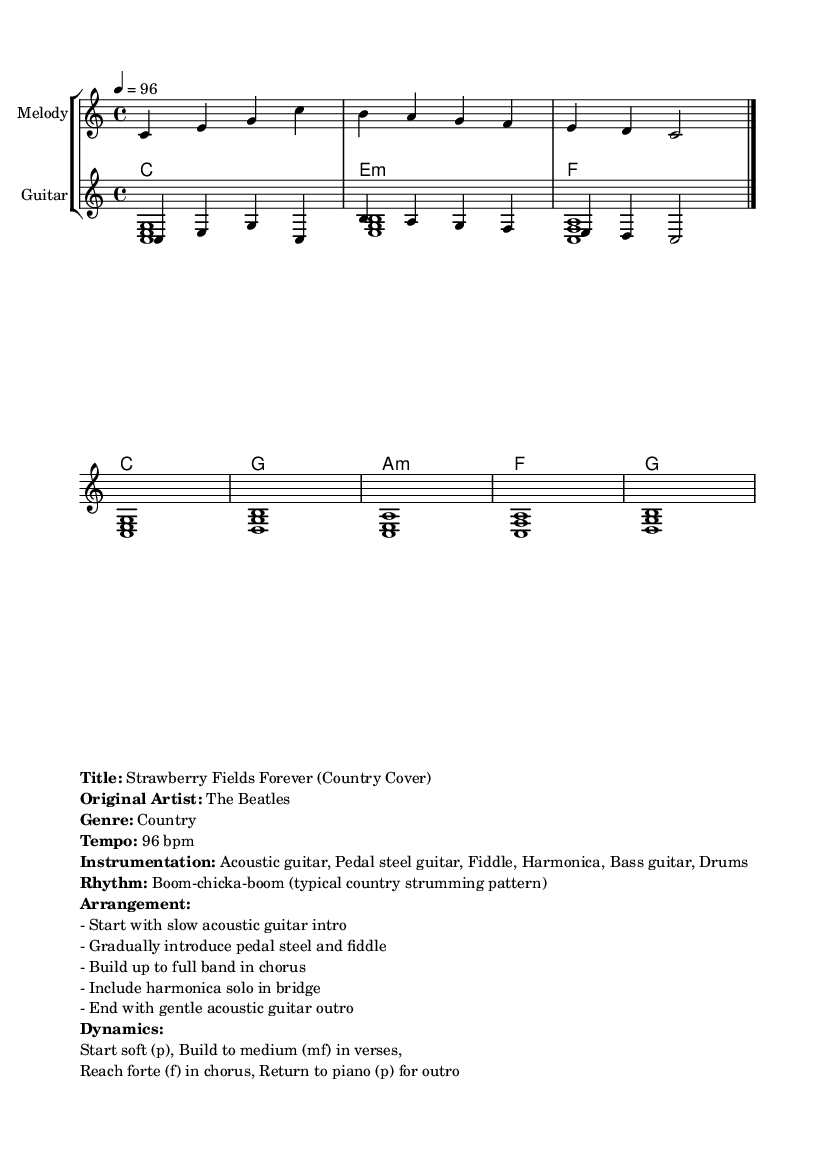What is the key signature of this music? The key signature is C major, which has no sharps or flats.
Answer: C major What is the time signature of this music? The time signature indicates that there are four beats per measure, which is denoted as 4/4.
Answer: 4/4 What is the tempo of this piece? The tempo marking is provided as 4 = 96, indicating the piece should be played at 96 beats per minute.
Answer: 96 bpm What instruments are featured in this arrangement? The instrumentation lists acoustic guitar, pedal steel guitar, fiddle, harmonica, bass guitar, and drums as the primary instruments used in the arrangement.
Answer: Acoustic guitar, Pedal steel guitar, Fiddle, Harmonica, Bass guitar, Drums How does the dynamics progress in this piece? The dynamics start softly (p), build to a medium volume (mf) in the verses, reach a loud volume (f) in the chorus, and return to soft (p) for the outro.
Answer: p, mf, f, p What is the characteristic strumming pattern mentioned for this country cover? The rhythm used is described as a "boom-chicka-boom" pattern, which is typical of country music.
Answer: Boom-chicka-boom In what section does the harmonica solo occur? The arrangement specifies that the harmonica solo takes place in the bridge section of the song.
Answer: Bridge 